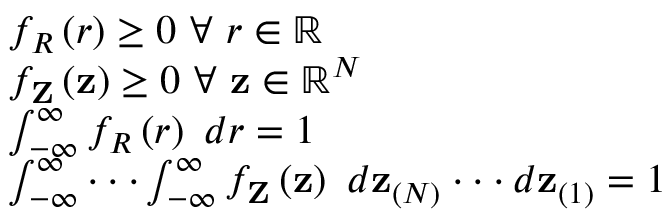<formula> <loc_0><loc_0><loc_500><loc_500>\begin{array} { r l } & { f _ { R } \left ( r \right ) \geq 0 \ \forall \ r \in \mathbb { R } } \\ & { f _ { Z } \left ( z \right ) \geq 0 \ \forall \ z \in \mathbb { R } ^ { N } } \\ & { \int _ { - \infty } ^ { \infty } f _ { R } \left ( r \right ) \ d r = 1 } \\ & { \int _ { - \infty } ^ { \infty } \cdot \cdot \cdot \int _ { - \infty } ^ { \infty } f _ { Z } \left ( z \right ) \ d z _ { ( N ) } \cdot \cdot \cdot d z _ { ( 1 ) } = 1 } \end{array}</formula> 